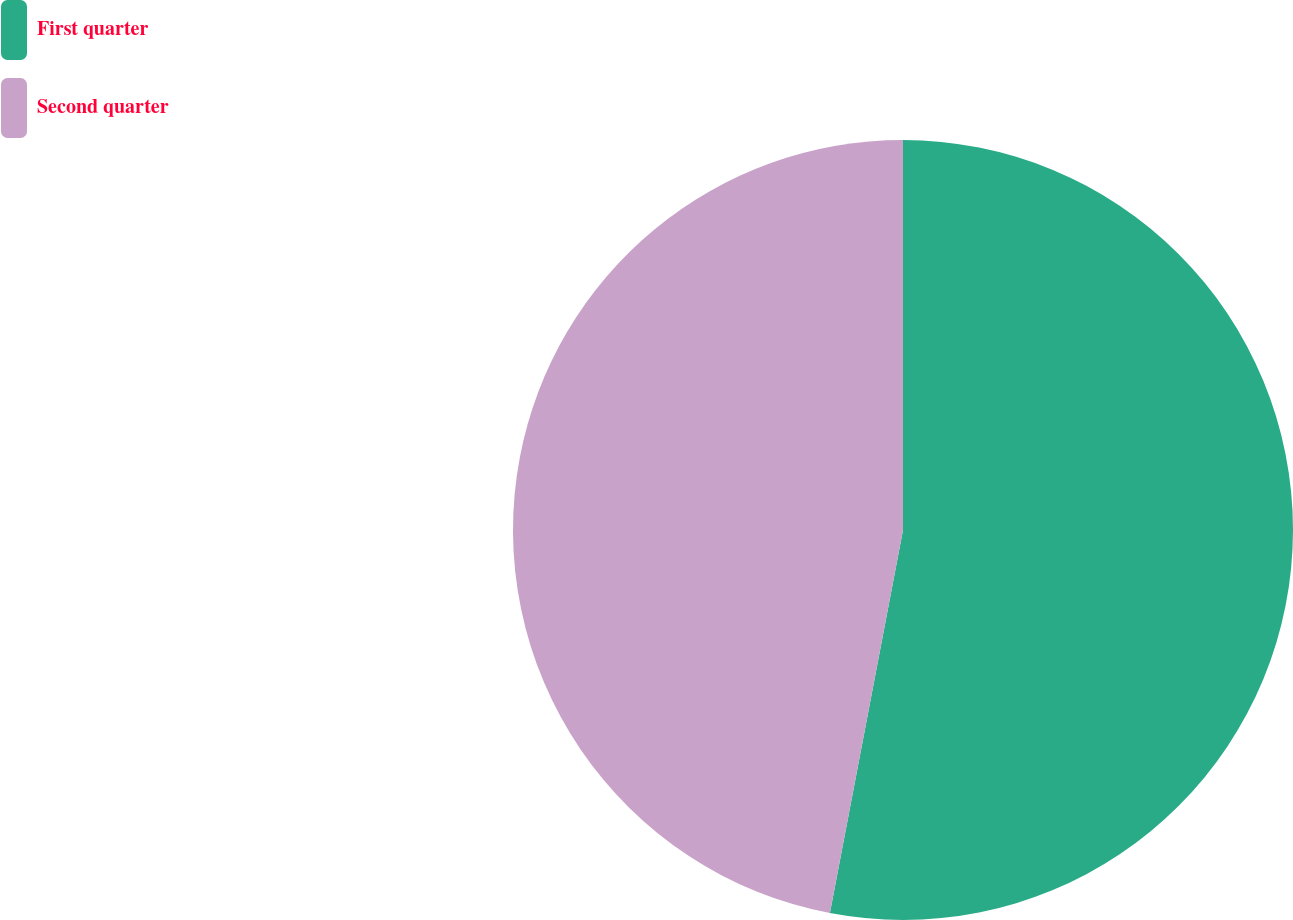Convert chart. <chart><loc_0><loc_0><loc_500><loc_500><pie_chart><fcel>First quarter<fcel>Second quarter<nl><fcel>53.0%<fcel>47.0%<nl></chart> 